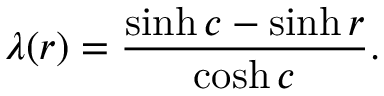Convert formula to latex. <formula><loc_0><loc_0><loc_500><loc_500>\lambda ( r ) = \frac { \sinh c - \sinh r } { \cosh c } .</formula> 